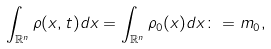Convert formula to latex. <formula><loc_0><loc_0><loc_500><loc_500>\int _ { \mathbb { R } ^ { n } } \rho ( x , t ) d x = \int _ { \mathbb { R } ^ { n } } \rho _ { 0 } ( x ) d x \colon = m _ { 0 } ,</formula> 